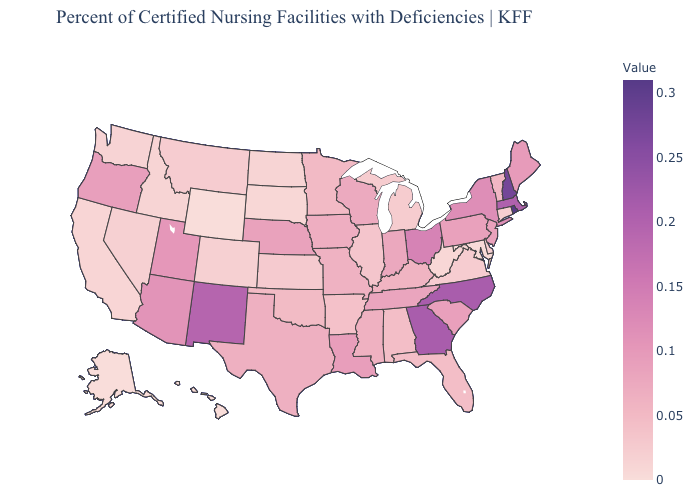Does Rhode Island have the highest value in the USA?
Quick response, please. Yes. Is the legend a continuous bar?
Write a very short answer. Yes. Does Minnesota have the lowest value in the MidWest?
Be succinct. No. Which states have the lowest value in the Northeast?
Short answer required. Connecticut. 